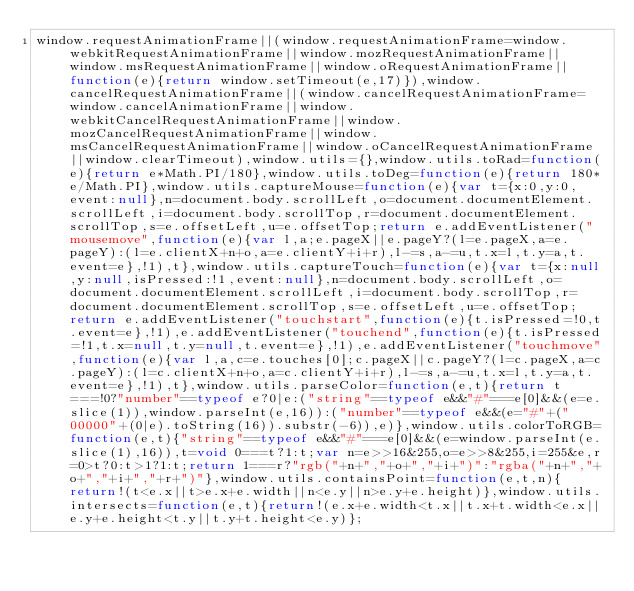<code> <loc_0><loc_0><loc_500><loc_500><_JavaScript_>window.requestAnimationFrame||(window.requestAnimationFrame=window.webkitRequestAnimationFrame||window.mozRequestAnimationFrame||window.msRequestAnimationFrame||window.oRequestAnimationFrame||function(e){return window.setTimeout(e,17)}),window.cancelRequestAnimationFrame||(window.cancelRequestAnimationFrame=window.cancelAnimationFrame||window.webkitCancelRequestAnimationFrame||window.mozCancelRequestAnimationFrame||window.msCancelRequestAnimationFrame||window.oCancelRequestAnimationFrame||window.clearTimeout),window.utils={},window.utils.toRad=function(e){return e*Math.PI/180},window.utils.toDeg=function(e){return 180*e/Math.PI},window.utils.captureMouse=function(e){var t={x:0,y:0,event:null},n=document.body.scrollLeft,o=document.documentElement.scrollLeft,i=document.body.scrollTop,r=document.documentElement.scrollTop,s=e.offsetLeft,u=e.offsetTop;return e.addEventListener("mousemove",function(e){var l,a;e.pageX||e.pageY?(l=e.pageX,a=e.pageY):(l=e.clientX+n+o,a=e.clientY+i+r),l-=s,a-=u,t.x=l,t.y=a,t.event=e},!1),t},window.utils.captureTouch=function(e){var t={x:null,y:null,isPressed:!1,event:null},n=document.body.scrollLeft,o=document.documentElement.scrollLeft,i=document.body.scrollTop,r=document.documentElement.scrollTop,s=e.offsetLeft,u=e.offsetTop;return e.addEventListener("touchstart",function(e){t.isPressed=!0,t.event=e},!1),e.addEventListener("touchend",function(e){t.isPressed=!1,t.x=null,t.y=null,t.event=e},!1),e.addEventListener("touchmove",function(e){var l,a,c=e.touches[0];c.pageX||c.pageY?(l=c.pageX,a=c.pageY):(l=c.clientX+n+o,a=c.clientY+i+r),l-=s,a-=u,t.x=l,t.y=a,t.event=e},!1),t},window.utils.parseColor=function(e,t){return t===!0?"number"==typeof e?0|e:("string"==typeof e&&"#"===e[0]&&(e=e.slice(1)),window.parseInt(e,16)):("number"==typeof e&&(e="#"+("00000"+(0|e).toString(16)).substr(-6)),e)},window.utils.colorToRGB=function(e,t){"string"==typeof e&&"#"===e[0]&&(e=window.parseInt(e.slice(1),16)),t=void 0===t?1:t;var n=e>>16&255,o=e>>8&255,i=255&e,r=0>t?0:t>1?1:t;return 1===r?"rgb("+n+","+o+","+i+")":"rgba("+n+","+o+","+i+","+r+")"},window.utils.containsPoint=function(e,t,n){return!(t<e.x||t>e.x+e.width||n<e.y||n>e.y+e.height)},window.utils.intersects=function(e,t){return!(e.x+e.width<t.x||t.x+t.width<e.x||e.y+e.height<t.y||t.y+t.height<e.y)};
</code> 